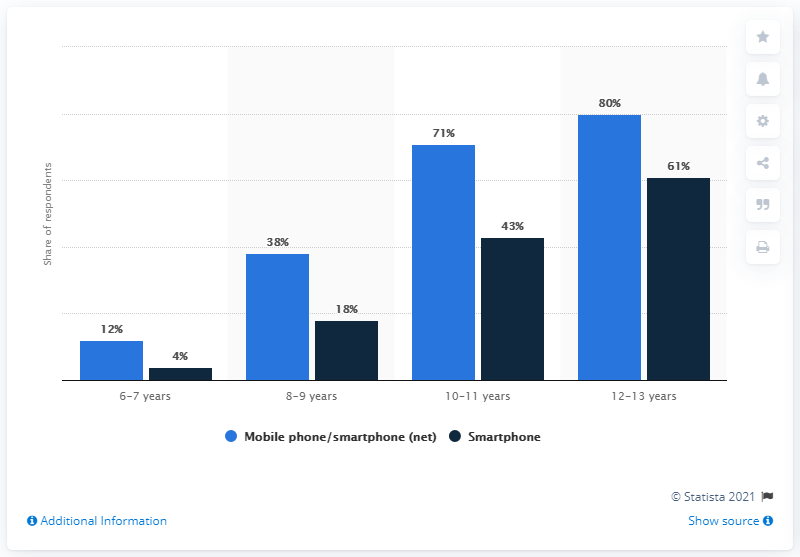List a handful of essential elements in this visual. According to recent studies, mobile phone ownership among 6-7 year olds is relatively low, with only a small percentage of this age group owning a mobile phone. According to the survey, approximately 12% of children between the ages of six and seven owned a mobile phone. According to the data, 4% of children were internet-enabled smartphone owners. The total percentage of ownership of mobile phones and smart phones among 6-7 year olds is 16%. 